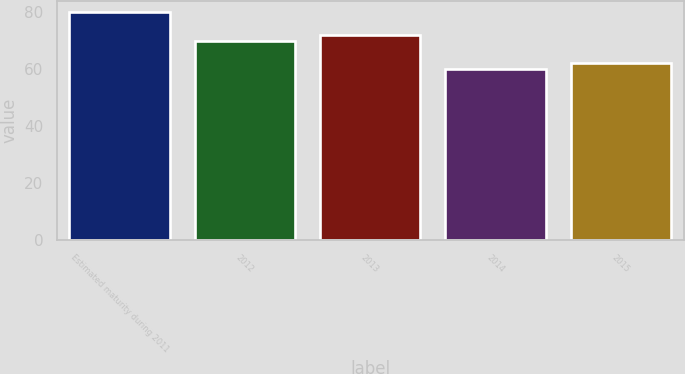Convert chart. <chart><loc_0><loc_0><loc_500><loc_500><bar_chart><fcel>Estimated maturity during 2011<fcel>2012<fcel>2013<fcel>2014<fcel>2015<nl><fcel>80<fcel>70<fcel>72<fcel>60<fcel>62<nl></chart> 